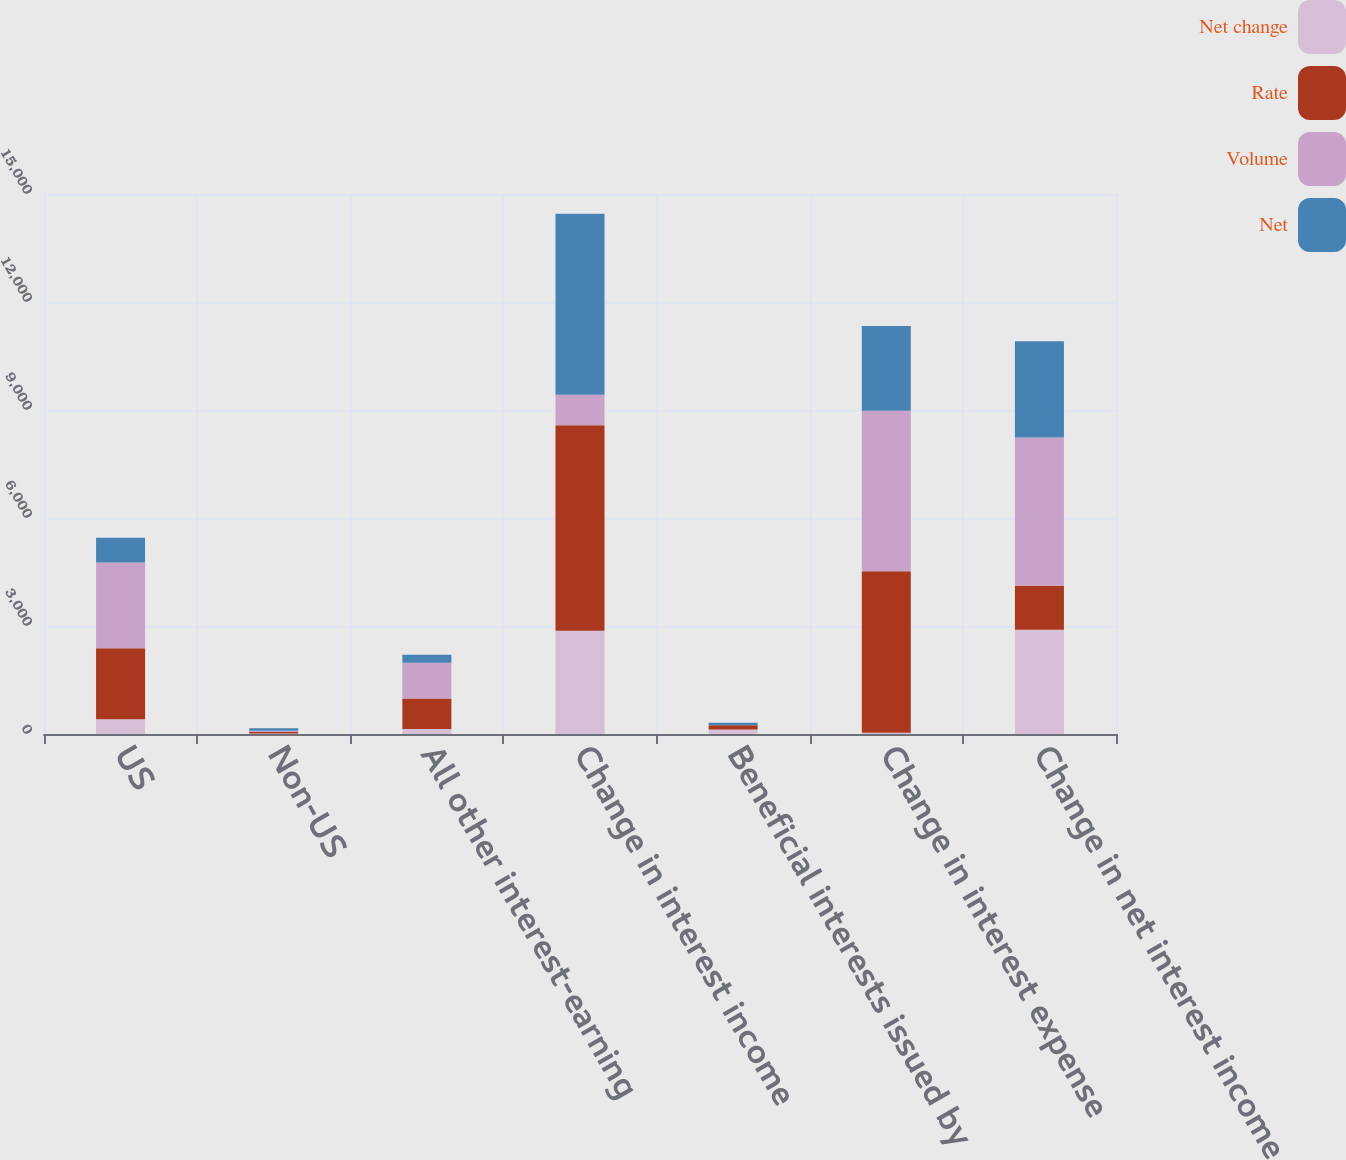Convert chart to OTSL. <chart><loc_0><loc_0><loc_500><loc_500><stacked_bar_chart><ecel><fcel>US<fcel>Non-US<fcel>All other interest-earning<fcel>Change in interest income<fcel>Beneficial interests issued by<fcel>Change in interest expense<fcel>Change in net interest income<nl><fcel>Net change<fcel>410<fcel>17<fcel>137<fcel>2865<fcel>122<fcel>33<fcel>2898<nl><fcel>Rate<fcel>1973<fcel>44<fcel>851<fcel>5710<fcel>121<fcel>4490<fcel>1220<nl><fcel>Volume<fcel>2383<fcel>27<fcel>988<fcel>851<fcel>1<fcel>4457<fcel>4118<nl><fcel>Net<fcel>687<fcel>74<fcel>223<fcel>5027<fcel>69<fcel>2355<fcel>2672<nl></chart> 